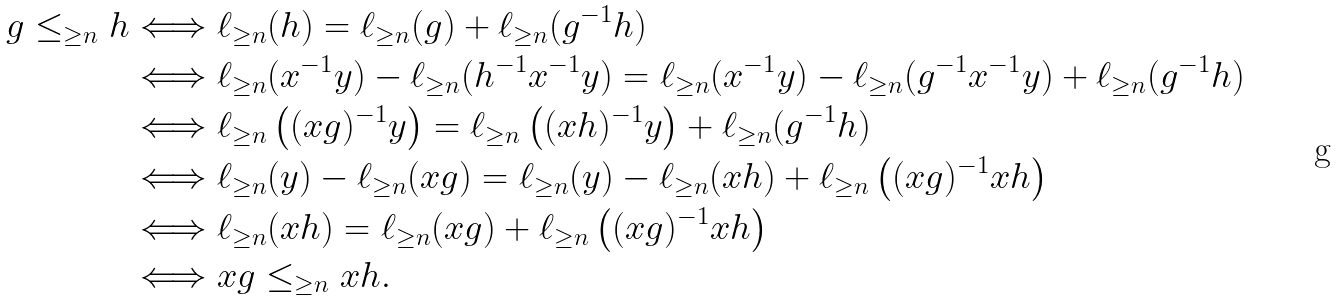Convert formula to latex. <formula><loc_0><loc_0><loc_500><loc_500>g \leq _ { \geq n } h & \Longleftrightarrow \ell _ { \geq n } ( h ) = \ell _ { \geq n } ( g ) + \ell _ { \geq n } ( g ^ { - 1 } h ) \\ & \Longleftrightarrow \ell _ { \geq n } ( x ^ { - 1 } y ) - \ell _ { \geq n } ( h ^ { - 1 } x ^ { - 1 } y ) = \ell _ { \geq n } ( x ^ { - 1 } y ) - \ell _ { \geq n } ( g ^ { - 1 } x ^ { - 1 } y ) + \ell _ { \geq n } ( g ^ { - 1 } h ) \\ & \Longleftrightarrow \ell _ { \geq n } \left ( ( x g ) ^ { - 1 } y \right ) = \ell _ { \geq n } \left ( ( x h ) ^ { - 1 } y \right ) + \ell _ { \geq n } ( g ^ { - 1 } h ) \\ & \Longleftrightarrow \ell _ { \geq n } ( y ) - \ell _ { \geq n } ( x g ) = \ell _ { \geq n } ( y ) - \ell _ { \geq n } ( x h ) + \ell _ { \geq n } \left ( ( x g ) ^ { - 1 } x h \right ) \\ & \Longleftrightarrow \ell _ { \geq n } ( x h ) = \ell _ { \geq n } ( x g ) + \ell _ { \geq n } \left ( ( x g ) ^ { - 1 } x h \right ) \\ & \Longleftrightarrow x g \leq _ { \geq n } x h .</formula> 